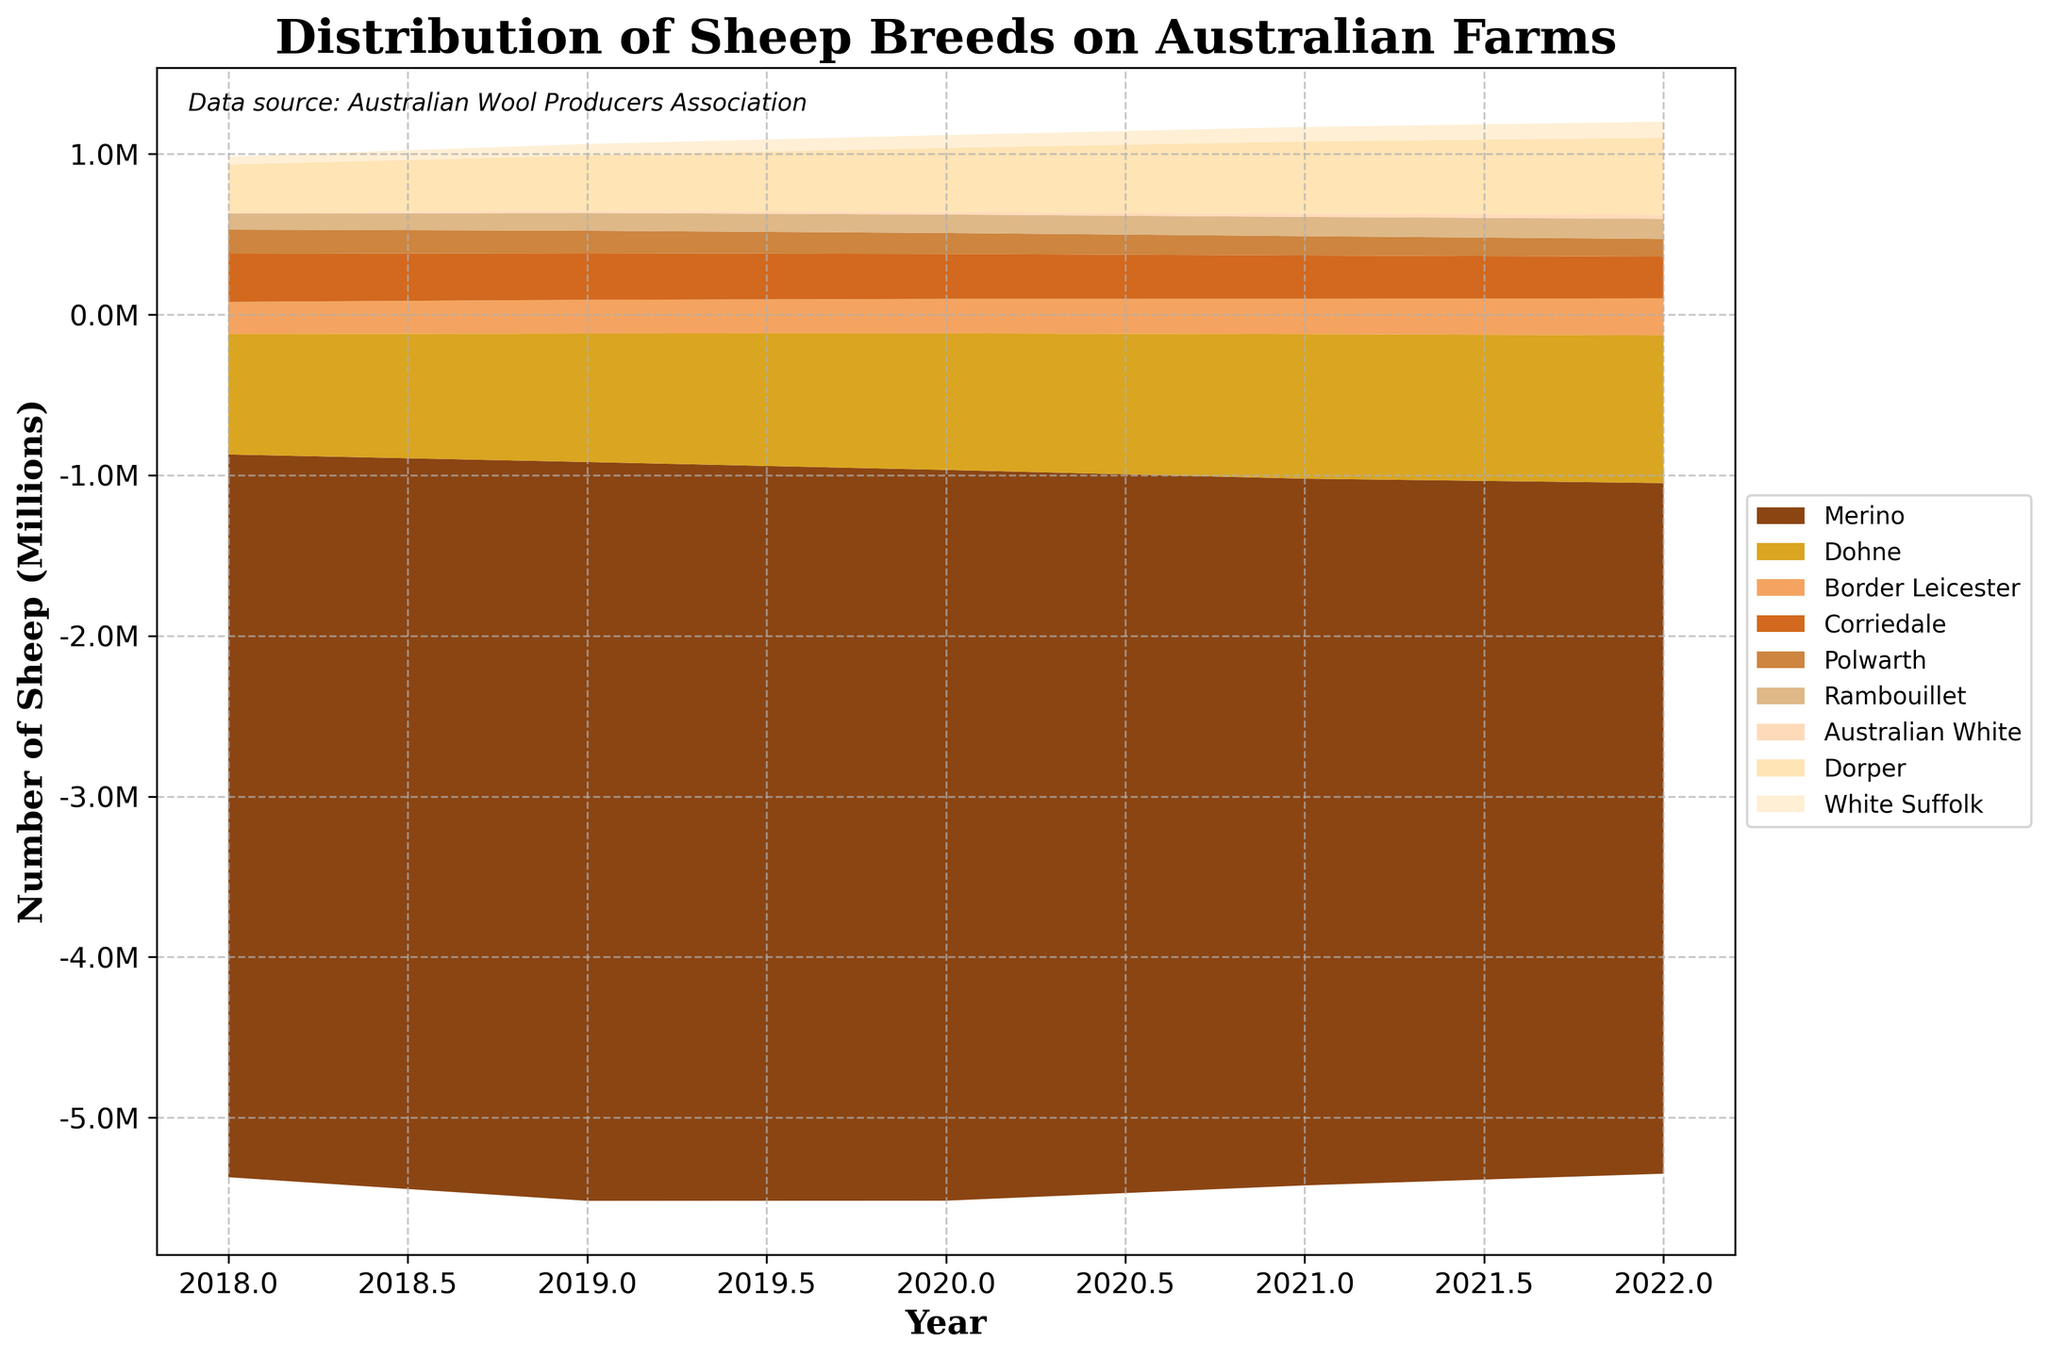How many breeds of sheep are depicted in the figure? Count the number of unique layers representing different breeds in the stream graph.
Answer: 9 What is the trend for Merino sheep from 2018 to 2022? Observe the layer corresponding to Merino sheep to see if it increases, decreases, or remains constant between 2018 and 2022.
Answer: Decreasing Which year had the highest number of Dohne sheep? Find the peak within the Dohne layer on the stream graph.
Answer: 2022 Between Merino and Dorper breeds, which one shows a more consistent decline over the years? Compare the trend lines for Merino and Dorper sheep from 2018 to 2022 to see which one shows a steadier decline.
Answer: Merino What is the approximate number of Australian White sheep in 2020? Look at the Australian White layer in the stream graph and estimate the value for the year 2020.
Answer: 15,000 How does the number of Corriedale sheep change from 2018 to 2022? Observe the layer corresponding to Corriedale sheep and note the number in 2018 and the number in 2022. Subtract the later value from the earlier value.
Answer: Decreases by 40,000 Which breed shows an upward trend across all years? Identify the layer that consistently increases from 2018 to 2022.
Answer: Dohne What is the total number of sheep for all breeds in 2020? Sum the values of all layers for the year 2020.
Answer: 6,635,000 Compare the proportion of White Suffolk sheep to Merino sheep in 2022. Calculate the ratio of the number of White Suffolk sheep to the number of Merino sheep for 2022.
Answer: About 1:43 Which breed had the lowest number of sheep in 2018 and how many were there? Identify the smallest layer in 2018 and read its value.
Answer: Australian White, 5,000 